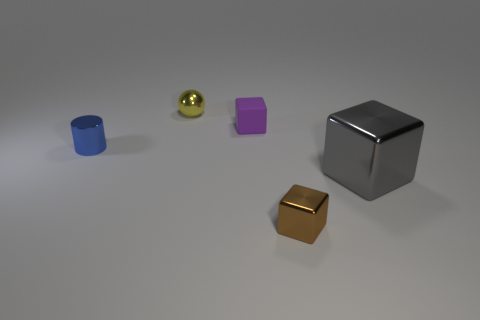Add 2 tiny yellow balls. How many objects exist? 7 Subtract all cylinders. How many objects are left? 4 Subtract 0 red cubes. How many objects are left? 5 Subtract all gray metallic cylinders. Subtract all tiny yellow objects. How many objects are left? 4 Add 1 small blue metallic cylinders. How many small blue metallic cylinders are left? 2 Add 2 tiny purple rubber blocks. How many tiny purple rubber blocks exist? 3 